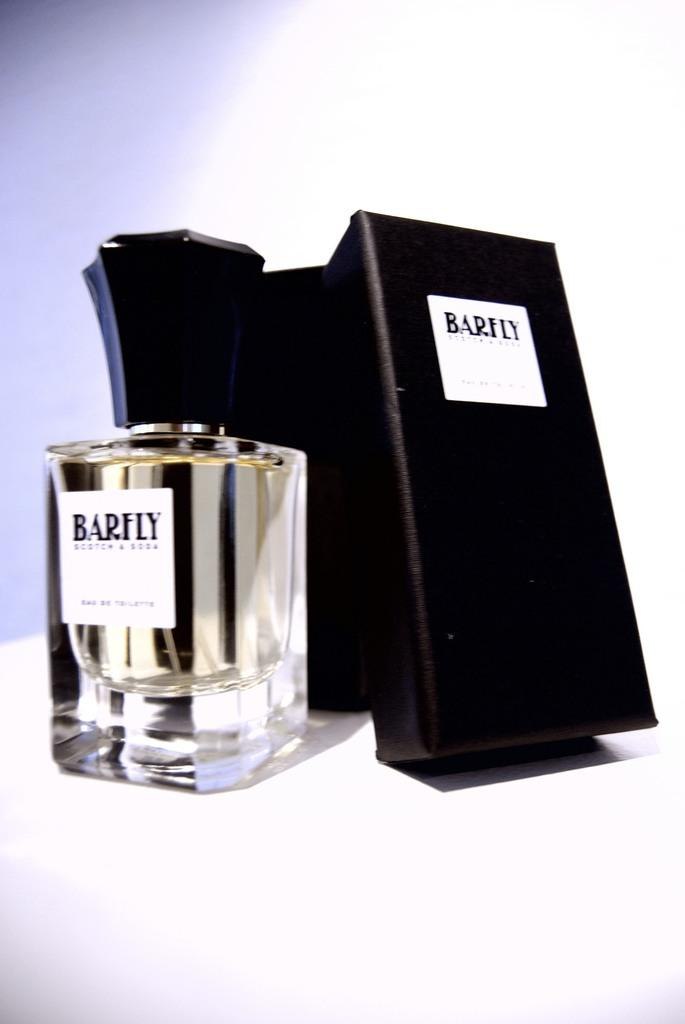<image>
Create a compact narrative representing the image presented. a glass item with barfly on the top 